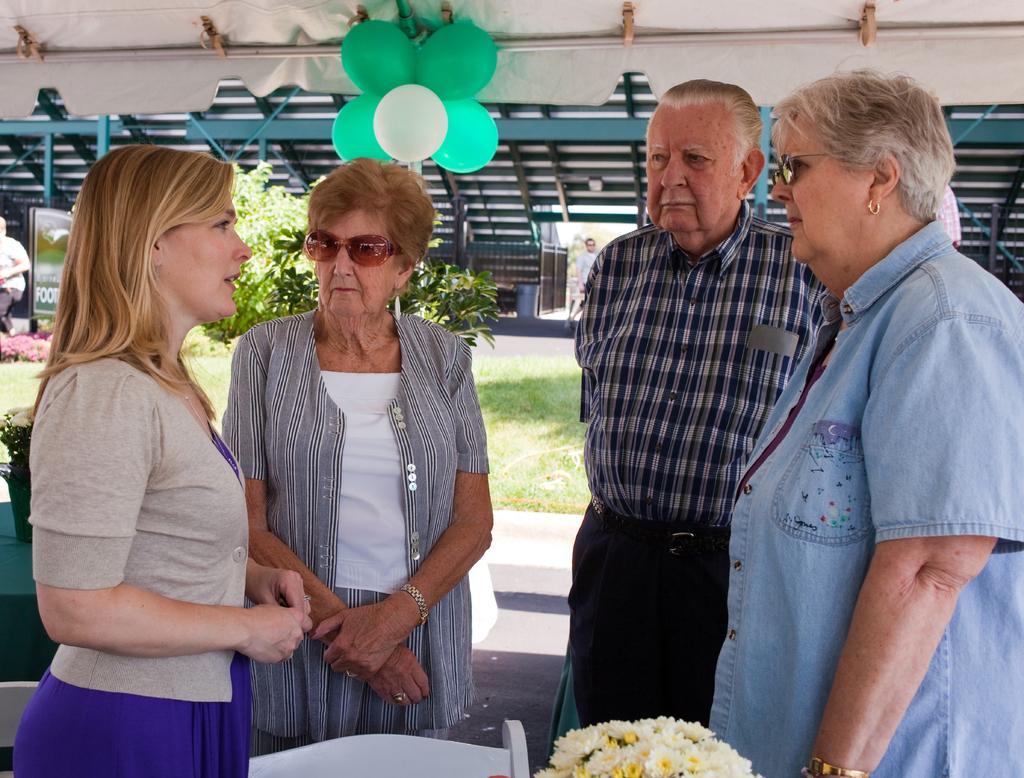Please provide a concise description of this image. In this image there are a few people standing and talking with each other, in front of them there are flowers and a chair, behind them there is grass on the surface and a tree, at the top of the image there are balloons. 